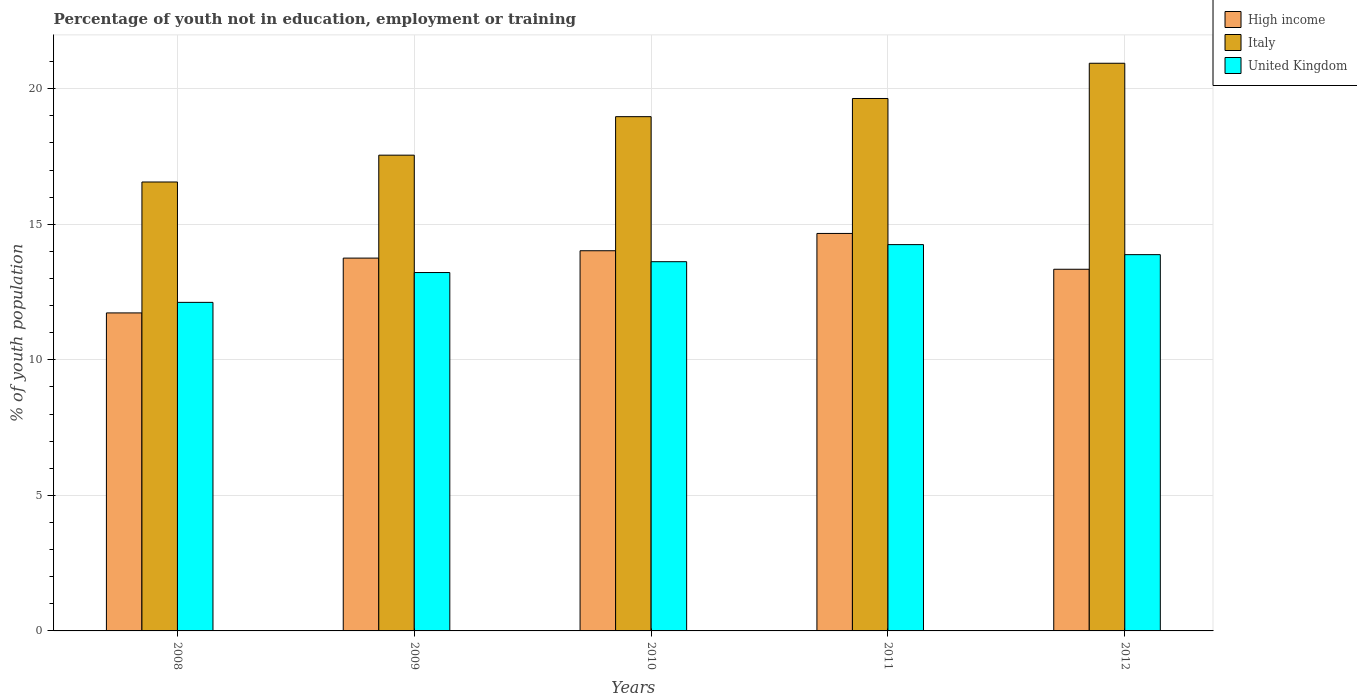How many groups of bars are there?
Your answer should be compact. 5. Are the number of bars per tick equal to the number of legend labels?
Make the answer very short. Yes. How many bars are there on the 2nd tick from the left?
Ensure brevity in your answer.  3. How many bars are there on the 5th tick from the right?
Provide a succinct answer. 3. What is the label of the 5th group of bars from the left?
Your answer should be very brief. 2012. What is the percentage of unemployed youth population in in High income in 2010?
Ensure brevity in your answer.  14.02. Across all years, what is the maximum percentage of unemployed youth population in in United Kingdom?
Make the answer very short. 14.25. Across all years, what is the minimum percentage of unemployed youth population in in High income?
Give a very brief answer. 11.73. In which year was the percentage of unemployed youth population in in High income maximum?
Your answer should be compact. 2011. What is the total percentage of unemployed youth population in in Italy in the graph?
Keep it short and to the point. 93.66. What is the difference between the percentage of unemployed youth population in in High income in 2010 and that in 2011?
Offer a terse response. -0.64. What is the difference between the percentage of unemployed youth population in in United Kingdom in 2008 and the percentage of unemployed youth population in in High income in 2009?
Keep it short and to the point. -1.63. What is the average percentage of unemployed youth population in in United Kingdom per year?
Ensure brevity in your answer.  13.42. In the year 2008, what is the difference between the percentage of unemployed youth population in in United Kingdom and percentage of unemployed youth population in in Italy?
Offer a terse response. -4.44. What is the ratio of the percentage of unemployed youth population in in United Kingdom in 2009 to that in 2010?
Offer a very short reply. 0.97. Is the percentage of unemployed youth population in in High income in 2010 less than that in 2011?
Give a very brief answer. Yes. Is the difference between the percentage of unemployed youth population in in United Kingdom in 2010 and 2011 greater than the difference between the percentage of unemployed youth population in in Italy in 2010 and 2011?
Keep it short and to the point. Yes. What is the difference between the highest and the second highest percentage of unemployed youth population in in United Kingdom?
Provide a short and direct response. 0.37. What is the difference between the highest and the lowest percentage of unemployed youth population in in United Kingdom?
Offer a terse response. 2.13. In how many years, is the percentage of unemployed youth population in in High income greater than the average percentage of unemployed youth population in in High income taken over all years?
Offer a very short reply. 3. Are all the bars in the graph horizontal?
Provide a succinct answer. No. What is the difference between two consecutive major ticks on the Y-axis?
Ensure brevity in your answer.  5. Where does the legend appear in the graph?
Provide a succinct answer. Top right. How many legend labels are there?
Offer a very short reply. 3. What is the title of the graph?
Ensure brevity in your answer.  Percentage of youth not in education, employment or training. What is the label or title of the X-axis?
Keep it short and to the point. Years. What is the label or title of the Y-axis?
Offer a very short reply. % of youth population. What is the % of youth population in High income in 2008?
Your answer should be very brief. 11.73. What is the % of youth population of Italy in 2008?
Your response must be concise. 16.56. What is the % of youth population of United Kingdom in 2008?
Provide a succinct answer. 12.12. What is the % of youth population of High income in 2009?
Ensure brevity in your answer.  13.75. What is the % of youth population in Italy in 2009?
Offer a very short reply. 17.55. What is the % of youth population in United Kingdom in 2009?
Ensure brevity in your answer.  13.22. What is the % of youth population of High income in 2010?
Your answer should be compact. 14.02. What is the % of youth population of Italy in 2010?
Provide a succinct answer. 18.97. What is the % of youth population in United Kingdom in 2010?
Your response must be concise. 13.62. What is the % of youth population in High income in 2011?
Provide a succinct answer. 14.66. What is the % of youth population of Italy in 2011?
Offer a terse response. 19.64. What is the % of youth population of United Kingdom in 2011?
Make the answer very short. 14.25. What is the % of youth population of High income in 2012?
Provide a short and direct response. 13.34. What is the % of youth population of Italy in 2012?
Offer a terse response. 20.94. What is the % of youth population in United Kingdom in 2012?
Make the answer very short. 13.88. Across all years, what is the maximum % of youth population in High income?
Your answer should be very brief. 14.66. Across all years, what is the maximum % of youth population in Italy?
Ensure brevity in your answer.  20.94. Across all years, what is the maximum % of youth population in United Kingdom?
Give a very brief answer. 14.25. Across all years, what is the minimum % of youth population of High income?
Your answer should be compact. 11.73. Across all years, what is the minimum % of youth population in Italy?
Keep it short and to the point. 16.56. Across all years, what is the minimum % of youth population of United Kingdom?
Make the answer very short. 12.12. What is the total % of youth population in High income in the graph?
Give a very brief answer. 67.51. What is the total % of youth population in Italy in the graph?
Your response must be concise. 93.66. What is the total % of youth population of United Kingdom in the graph?
Your answer should be very brief. 67.09. What is the difference between the % of youth population in High income in 2008 and that in 2009?
Provide a succinct answer. -2.02. What is the difference between the % of youth population of Italy in 2008 and that in 2009?
Offer a very short reply. -0.99. What is the difference between the % of youth population of High income in 2008 and that in 2010?
Give a very brief answer. -2.29. What is the difference between the % of youth population in Italy in 2008 and that in 2010?
Give a very brief answer. -2.41. What is the difference between the % of youth population in High income in 2008 and that in 2011?
Provide a short and direct response. -2.93. What is the difference between the % of youth population of Italy in 2008 and that in 2011?
Your response must be concise. -3.08. What is the difference between the % of youth population of United Kingdom in 2008 and that in 2011?
Your answer should be very brief. -2.13. What is the difference between the % of youth population of High income in 2008 and that in 2012?
Make the answer very short. -1.61. What is the difference between the % of youth population in Italy in 2008 and that in 2012?
Provide a short and direct response. -4.38. What is the difference between the % of youth population in United Kingdom in 2008 and that in 2012?
Your answer should be very brief. -1.76. What is the difference between the % of youth population in High income in 2009 and that in 2010?
Offer a terse response. -0.27. What is the difference between the % of youth population in Italy in 2009 and that in 2010?
Your answer should be compact. -1.42. What is the difference between the % of youth population of High income in 2009 and that in 2011?
Offer a terse response. -0.91. What is the difference between the % of youth population of Italy in 2009 and that in 2011?
Offer a very short reply. -2.09. What is the difference between the % of youth population of United Kingdom in 2009 and that in 2011?
Offer a terse response. -1.03. What is the difference between the % of youth population of High income in 2009 and that in 2012?
Ensure brevity in your answer.  0.41. What is the difference between the % of youth population in Italy in 2009 and that in 2012?
Offer a very short reply. -3.39. What is the difference between the % of youth population of United Kingdom in 2009 and that in 2012?
Make the answer very short. -0.66. What is the difference between the % of youth population of High income in 2010 and that in 2011?
Your response must be concise. -0.64. What is the difference between the % of youth population of Italy in 2010 and that in 2011?
Ensure brevity in your answer.  -0.67. What is the difference between the % of youth population of United Kingdom in 2010 and that in 2011?
Your answer should be compact. -0.63. What is the difference between the % of youth population of High income in 2010 and that in 2012?
Offer a terse response. 0.68. What is the difference between the % of youth population of Italy in 2010 and that in 2012?
Your answer should be very brief. -1.97. What is the difference between the % of youth population in United Kingdom in 2010 and that in 2012?
Provide a short and direct response. -0.26. What is the difference between the % of youth population of High income in 2011 and that in 2012?
Keep it short and to the point. 1.32. What is the difference between the % of youth population in United Kingdom in 2011 and that in 2012?
Keep it short and to the point. 0.37. What is the difference between the % of youth population of High income in 2008 and the % of youth population of Italy in 2009?
Provide a short and direct response. -5.82. What is the difference between the % of youth population of High income in 2008 and the % of youth population of United Kingdom in 2009?
Offer a terse response. -1.49. What is the difference between the % of youth population of Italy in 2008 and the % of youth population of United Kingdom in 2009?
Ensure brevity in your answer.  3.34. What is the difference between the % of youth population of High income in 2008 and the % of youth population of Italy in 2010?
Give a very brief answer. -7.24. What is the difference between the % of youth population in High income in 2008 and the % of youth population in United Kingdom in 2010?
Your response must be concise. -1.89. What is the difference between the % of youth population of Italy in 2008 and the % of youth population of United Kingdom in 2010?
Offer a very short reply. 2.94. What is the difference between the % of youth population of High income in 2008 and the % of youth population of Italy in 2011?
Provide a short and direct response. -7.91. What is the difference between the % of youth population in High income in 2008 and the % of youth population in United Kingdom in 2011?
Your answer should be compact. -2.52. What is the difference between the % of youth population of Italy in 2008 and the % of youth population of United Kingdom in 2011?
Offer a very short reply. 2.31. What is the difference between the % of youth population in High income in 2008 and the % of youth population in Italy in 2012?
Give a very brief answer. -9.21. What is the difference between the % of youth population in High income in 2008 and the % of youth population in United Kingdom in 2012?
Keep it short and to the point. -2.15. What is the difference between the % of youth population in Italy in 2008 and the % of youth population in United Kingdom in 2012?
Give a very brief answer. 2.68. What is the difference between the % of youth population in High income in 2009 and the % of youth population in Italy in 2010?
Give a very brief answer. -5.22. What is the difference between the % of youth population in High income in 2009 and the % of youth population in United Kingdom in 2010?
Your answer should be very brief. 0.13. What is the difference between the % of youth population in Italy in 2009 and the % of youth population in United Kingdom in 2010?
Keep it short and to the point. 3.93. What is the difference between the % of youth population in High income in 2009 and the % of youth population in Italy in 2011?
Give a very brief answer. -5.89. What is the difference between the % of youth population of High income in 2009 and the % of youth population of United Kingdom in 2011?
Ensure brevity in your answer.  -0.5. What is the difference between the % of youth population of Italy in 2009 and the % of youth population of United Kingdom in 2011?
Make the answer very short. 3.3. What is the difference between the % of youth population in High income in 2009 and the % of youth population in Italy in 2012?
Make the answer very short. -7.19. What is the difference between the % of youth population of High income in 2009 and the % of youth population of United Kingdom in 2012?
Offer a terse response. -0.13. What is the difference between the % of youth population of Italy in 2009 and the % of youth population of United Kingdom in 2012?
Give a very brief answer. 3.67. What is the difference between the % of youth population in High income in 2010 and the % of youth population in Italy in 2011?
Make the answer very short. -5.62. What is the difference between the % of youth population in High income in 2010 and the % of youth population in United Kingdom in 2011?
Offer a terse response. -0.23. What is the difference between the % of youth population of Italy in 2010 and the % of youth population of United Kingdom in 2011?
Provide a short and direct response. 4.72. What is the difference between the % of youth population of High income in 2010 and the % of youth population of Italy in 2012?
Provide a succinct answer. -6.92. What is the difference between the % of youth population of High income in 2010 and the % of youth population of United Kingdom in 2012?
Your response must be concise. 0.14. What is the difference between the % of youth population in Italy in 2010 and the % of youth population in United Kingdom in 2012?
Your answer should be compact. 5.09. What is the difference between the % of youth population in High income in 2011 and the % of youth population in Italy in 2012?
Make the answer very short. -6.28. What is the difference between the % of youth population in High income in 2011 and the % of youth population in United Kingdom in 2012?
Your response must be concise. 0.78. What is the difference between the % of youth population in Italy in 2011 and the % of youth population in United Kingdom in 2012?
Your answer should be compact. 5.76. What is the average % of youth population in High income per year?
Give a very brief answer. 13.5. What is the average % of youth population in Italy per year?
Your response must be concise. 18.73. What is the average % of youth population in United Kingdom per year?
Provide a succinct answer. 13.42. In the year 2008, what is the difference between the % of youth population of High income and % of youth population of Italy?
Ensure brevity in your answer.  -4.83. In the year 2008, what is the difference between the % of youth population of High income and % of youth population of United Kingdom?
Offer a terse response. -0.39. In the year 2008, what is the difference between the % of youth population of Italy and % of youth population of United Kingdom?
Your answer should be compact. 4.44. In the year 2009, what is the difference between the % of youth population in High income and % of youth population in Italy?
Provide a short and direct response. -3.8. In the year 2009, what is the difference between the % of youth population in High income and % of youth population in United Kingdom?
Give a very brief answer. 0.53. In the year 2009, what is the difference between the % of youth population in Italy and % of youth population in United Kingdom?
Your answer should be very brief. 4.33. In the year 2010, what is the difference between the % of youth population in High income and % of youth population in Italy?
Your answer should be very brief. -4.95. In the year 2010, what is the difference between the % of youth population of High income and % of youth population of United Kingdom?
Your answer should be very brief. 0.4. In the year 2010, what is the difference between the % of youth population of Italy and % of youth population of United Kingdom?
Your answer should be very brief. 5.35. In the year 2011, what is the difference between the % of youth population in High income and % of youth population in Italy?
Ensure brevity in your answer.  -4.98. In the year 2011, what is the difference between the % of youth population of High income and % of youth population of United Kingdom?
Offer a terse response. 0.41. In the year 2011, what is the difference between the % of youth population in Italy and % of youth population in United Kingdom?
Your response must be concise. 5.39. In the year 2012, what is the difference between the % of youth population in High income and % of youth population in Italy?
Your answer should be compact. -7.6. In the year 2012, what is the difference between the % of youth population of High income and % of youth population of United Kingdom?
Your response must be concise. -0.54. In the year 2012, what is the difference between the % of youth population of Italy and % of youth population of United Kingdom?
Ensure brevity in your answer.  7.06. What is the ratio of the % of youth population in High income in 2008 to that in 2009?
Provide a succinct answer. 0.85. What is the ratio of the % of youth population in Italy in 2008 to that in 2009?
Ensure brevity in your answer.  0.94. What is the ratio of the % of youth population in United Kingdom in 2008 to that in 2009?
Your response must be concise. 0.92. What is the ratio of the % of youth population of High income in 2008 to that in 2010?
Keep it short and to the point. 0.84. What is the ratio of the % of youth population of Italy in 2008 to that in 2010?
Your answer should be very brief. 0.87. What is the ratio of the % of youth population in United Kingdom in 2008 to that in 2010?
Ensure brevity in your answer.  0.89. What is the ratio of the % of youth population in High income in 2008 to that in 2011?
Provide a short and direct response. 0.8. What is the ratio of the % of youth population in Italy in 2008 to that in 2011?
Provide a succinct answer. 0.84. What is the ratio of the % of youth population in United Kingdom in 2008 to that in 2011?
Keep it short and to the point. 0.85. What is the ratio of the % of youth population of High income in 2008 to that in 2012?
Your answer should be compact. 0.88. What is the ratio of the % of youth population in Italy in 2008 to that in 2012?
Offer a very short reply. 0.79. What is the ratio of the % of youth population in United Kingdom in 2008 to that in 2012?
Your response must be concise. 0.87. What is the ratio of the % of youth population of High income in 2009 to that in 2010?
Keep it short and to the point. 0.98. What is the ratio of the % of youth population of Italy in 2009 to that in 2010?
Give a very brief answer. 0.93. What is the ratio of the % of youth population of United Kingdom in 2009 to that in 2010?
Your answer should be very brief. 0.97. What is the ratio of the % of youth population of High income in 2009 to that in 2011?
Your answer should be compact. 0.94. What is the ratio of the % of youth population of Italy in 2009 to that in 2011?
Offer a very short reply. 0.89. What is the ratio of the % of youth population of United Kingdom in 2009 to that in 2011?
Offer a very short reply. 0.93. What is the ratio of the % of youth population of High income in 2009 to that in 2012?
Your answer should be very brief. 1.03. What is the ratio of the % of youth population in Italy in 2009 to that in 2012?
Keep it short and to the point. 0.84. What is the ratio of the % of youth population in United Kingdom in 2009 to that in 2012?
Provide a short and direct response. 0.95. What is the ratio of the % of youth population in High income in 2010 to that in 2011?
Provide a succinct answer. 0.96. What is the ratio of the % of youth population in Italy in 2010 to that in 2011?
Your answer should be very brief. 0.97. What is the ratio of the % of youth population in United Kingdom in 2010 to that in 2011?
Your answer should be compact. 0.96. What is the ratio of the % of youth population in High income in 2010 to that in 2012?
Your answer should be very brief. 1.05. What is the ratio of the % of youth population of Italy in 2010 to that in 2012?
Ensure brevity in your answer.  0.91. What is the ratio of the % of youth population of United Kingdom in 2010 to that in 2012?
Provide a short and direct response. 0.98. What is the ratio of the % of youth population of High income in 2011 to that in 2012?
Provide a short and direct response. 1.1. What is the ratio of the % of youth population in Italy in 2011 to that in 2012?
Offer a terse response. 0.94. What is the ratio of the % of youth population in United Kingdom in 2011 to that in 2012?
Keep it short and to the point. 1.03. What is the difference between the highest and the second highest % of youth population in High income?
Provide a short and direct response. 0.64. What is the difference between the highest and the second highest % of youth population of Italy?
Your answer should be compact. 1.3. What is the difference between the highest and the second highest % of youth population in United Kingdom?
Your response must be concise. 0.37. What is the difference between the highest and the lowest % of youth population in High income?
Provide a succinct answer. 2.93. What is the difference between the highest and the lowest % of youth population in Italy?
Your answer should be compact. 4.38. What is the difference between the highest and the lowest % of youth population of United Kingdom?
Make the answer very short. 2.13. 